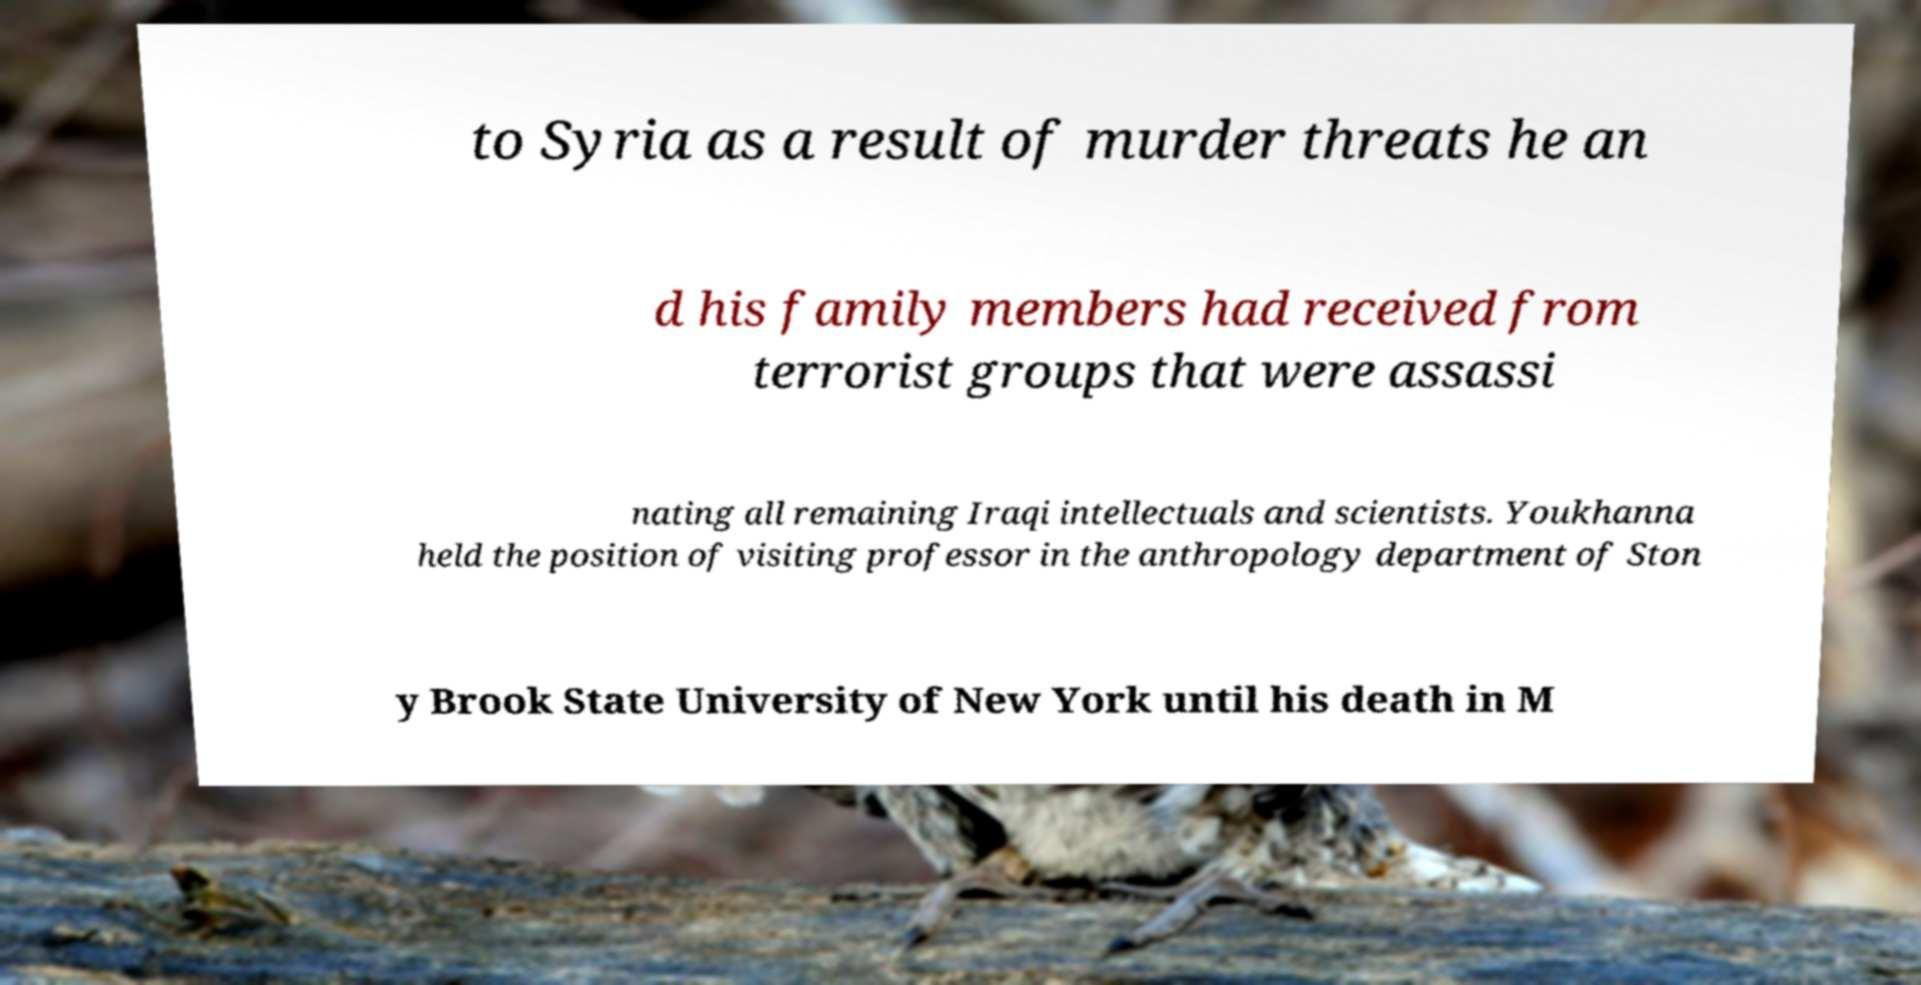Can you read and provide the text displayed in the image?This photo seems to have some interesting text. Can you extract and type it out for me? to Syria as a result of murder threats he an d his family members had received from terrorist groups that were assassi nating all remaining Iraqi intellectuals and scientists. Youkhanna held the position of visiting professor in the anthropology department of Ston y Brook State University of New York until his death in M 